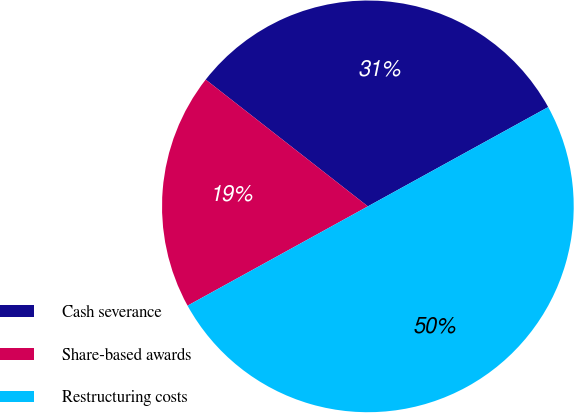Convert chart. <chart><loc_0><loc_0><loc_500><loc_500><pie_chart><fcel>Cash severance<fcel>Share-based awards<fcel>Restructuring costs<nl><fcel>31.43%<fcel>18.57%<fcel>50.0%<nl></chart> 